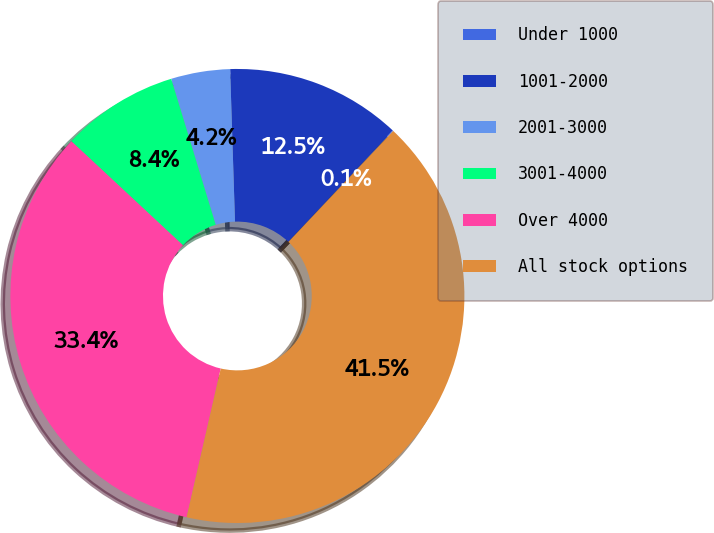Convert chart to OTSL. <chart><loc_0><loc_0><loc_500><loc_500><pie_chart><fcel>Under 1000<fcel>1001-2000<fcel>2001-3000<fcel>3001-4000<fcel>Over 4000<fcel>All stock options<nl><fcel>0.05%<fcel>12.5%<fcel>4.2%<fcel>8.35%<fcel>33.35%<fcel>41.54%<nl></chart> 